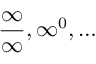<formula> <loc_0><loc_0><loc_500><loc_500>{ \frac { \infty } { \infty } } , \infty ^ { 0 } , \dots</formula> 